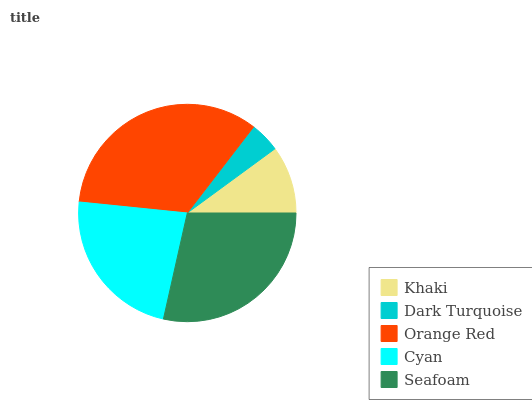Is Dark Turquoise the minimum?
Answer yes or no. Yes. Is Orange Red the maximum?
Answer yes or no. Yes. Is Orange Red the minimum?
Answer yes or no. No. Is Dark Turquoise the maximum?
Answer yes or no. No. Is Orange Red greater than Dark Turquoise?
Answer yes or no. Yes. Is Dark Turquoise less than Orange Red?
Answer yes or no. Yes. Is Dark Turquoise greater than Orange Red?
Answer yes or no. No. Is Orange Red less than Dark Turquoise?
Answer yes or no. No. Is Cyan the high median?
Answer yes or no. Yes. Is Cyan the low median?
Answer yes or no. Yes. Is Dark Turquoise the high median?
Answer yes or no. No. Is Khaki the low median?
Answer yes or no. No. 